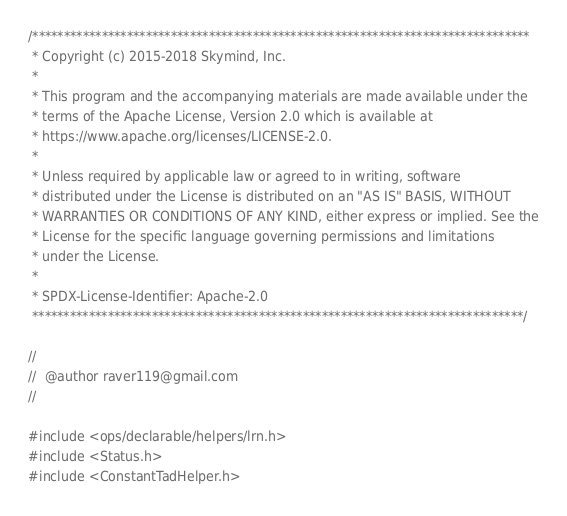<code> <loc_0><loc_0><loc_500><loc_500><_Cuda_>/*******************************************************************************
 * Copyright (c) 2015-2018 Skymind, Inc.
 *
 * This program and the accompanying materials are made available under the
 * terms of the Apache License, Version 2.0 which is available at
 * https://www.apache.org/licenses/LICENSE-2.0.
 *
 * Unless required by applicable law or agreed to in writing, software
 * distributed under the License is distributed on an "AS IS" BASIS, WITHOUT
 * WARRANTIES OR CONDITIONS OF ANY KIND, either express or implied. See the
 * License for the specific language governing permissions and limitations
 * under the License.
 *
 * SPDX-License-Identifier: Apache-2.0
 ******************************************************************************/

//
//  @author raver119@gmail.com
//

#include <ops/declarable/helpers/lrn.h>
#include <Status.h>
#include <ConstantTadHelper.h>
</code> 